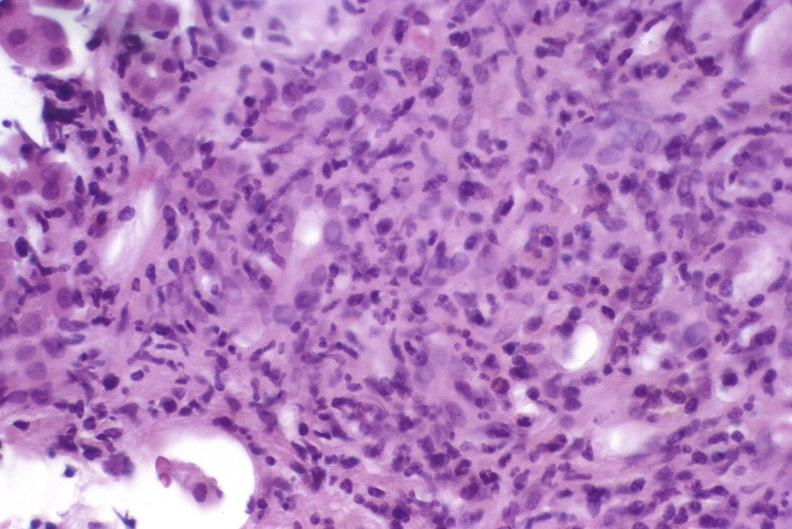what is present?
Answer the question using a single word or phrase. Liver 